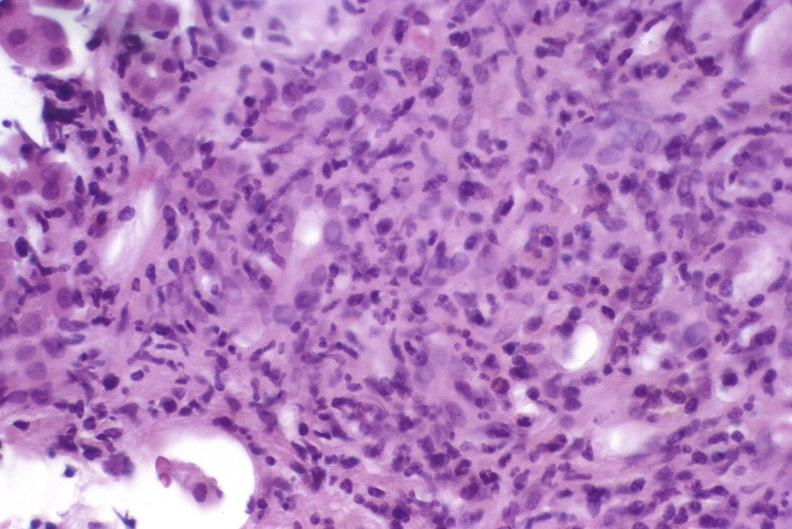what is present?
Answer the question using a single word or phrase. Liver 